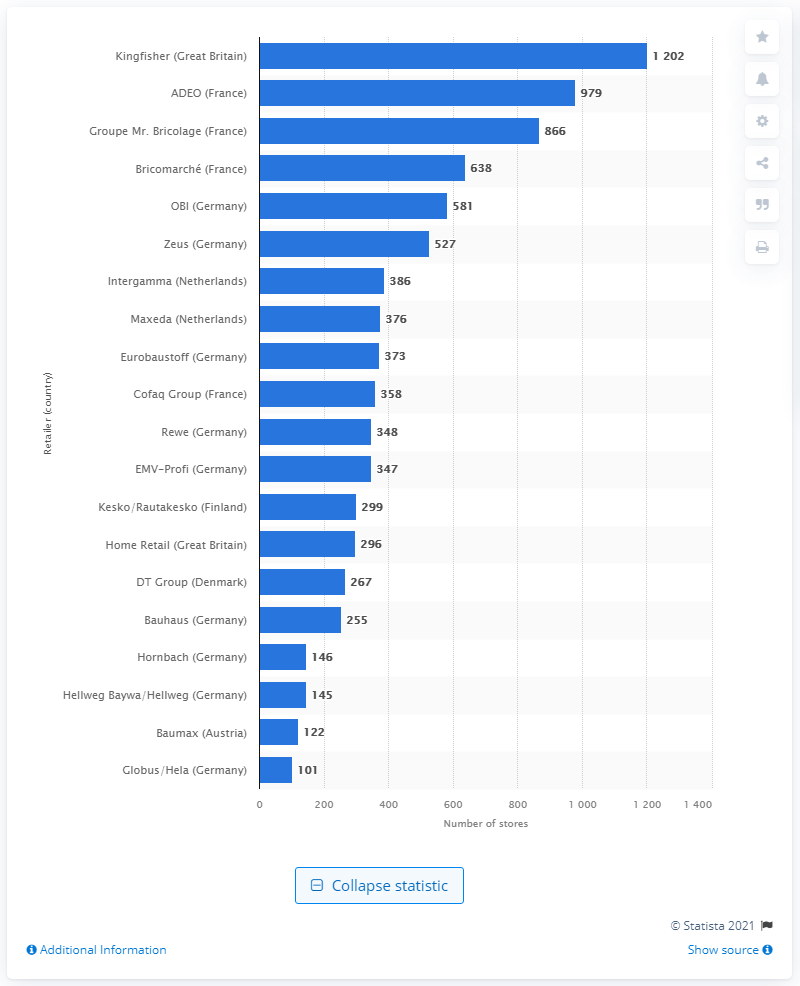Which country's retailers are the most represented in the top 10 of this statistic? Germany's retailers are the most represented in the top 10 of this statistic, with companies like OBI, Rewe, Bauhaus, and others contributing significantly to the country's presence. 